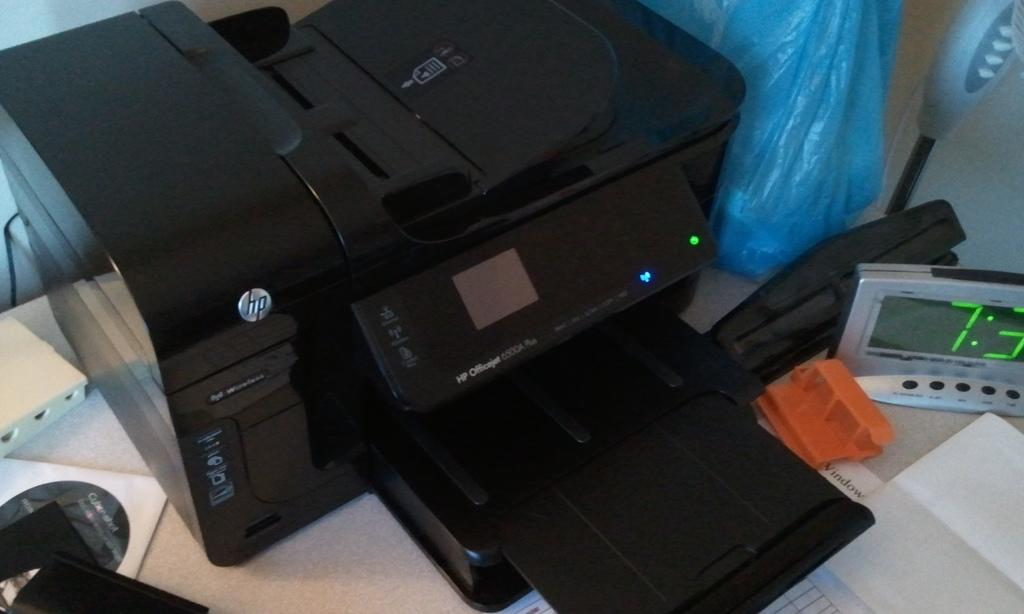What device is present on the table for measuring time? There is a digital timer on the table. What type of printer is on the table? There is an HP printer machine on the table. What color is the polythene cover on the table? The polythene cover on the table is blue. What type of storage medium is on the table? There is a compact disc in a cover on the table. What material is present on the table for writing or printing? There is paper on the table. Can you describe any other objects on the table? There are other unspecified objects on the table. What type of rail is present on the table? There is no rail present on the table. Can you provide the receipt for the printer on the table? There is no mention of a receipt in the image or the provided facts. What class is being taught in the image? There is no indication of a class or any teaching activity in the image. 